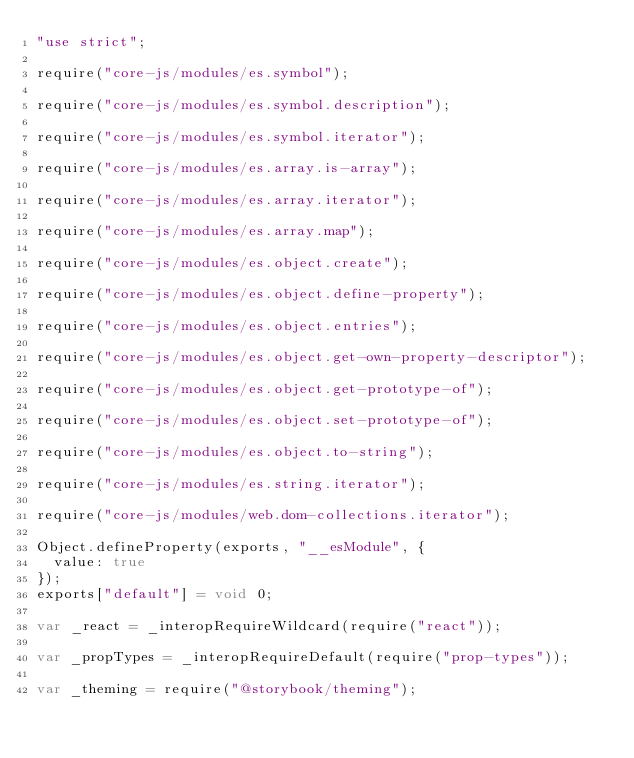Convert code to text. <code><loc_0><loc_0><loc_500><loc_500><_JavaScript_>"use strict";

require("core-js/modules/es.symbol");

require("core-js/modules/es.symbol.description");

require("core-js/modules/es.symbol.iterator");

require("core-js/modules/es.array.is-array");

require("core-js/modules/es.array.iterator");

require("core-js/modules/es.array.map");

require("core-js/modules/es.object.create");

require("core-js/modules/es.object.define-property");

require("core-js/modules/es.object.entries");

require("core-js/modules/es.object.get-own-property-descriptor");

require("core-js/modules/es.object.get-prototype-of");

require("core-js/modules/es.object.set-prototype-of");

require("core-js/modules/es.object.to-string");

require("core-js/modules/es.string.iterator");

require("core-js/modules/web.dom-collections.iterator");

Object.defineProperty(exports, "__esModule", {
  value: true
});
exports["default"] = void 0;

var _react = _interopRequireWildcard(require("react"));

var _propTypes = _interopRequireDefault(require("prop-types"));

var _theming = require("@storybook/theming");
</code> 